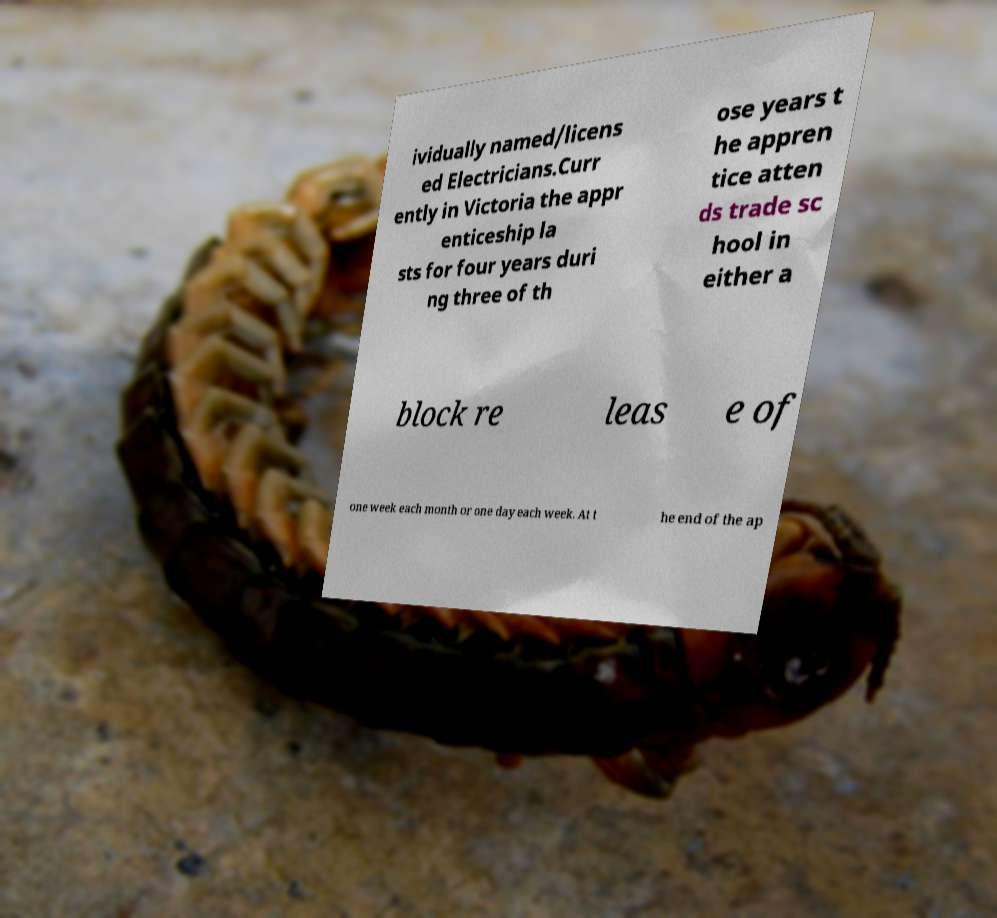I need the written content from this picture converted into text. Can you do that? ividually named/licens ed Electricians.Curr ently in Victoria the appr enticeship la sts for four years duri ng three of th ose years t he appren tice atten ds trade sc hool in either a block re leas e of one week each month or one day each week. At t he end of the ap 